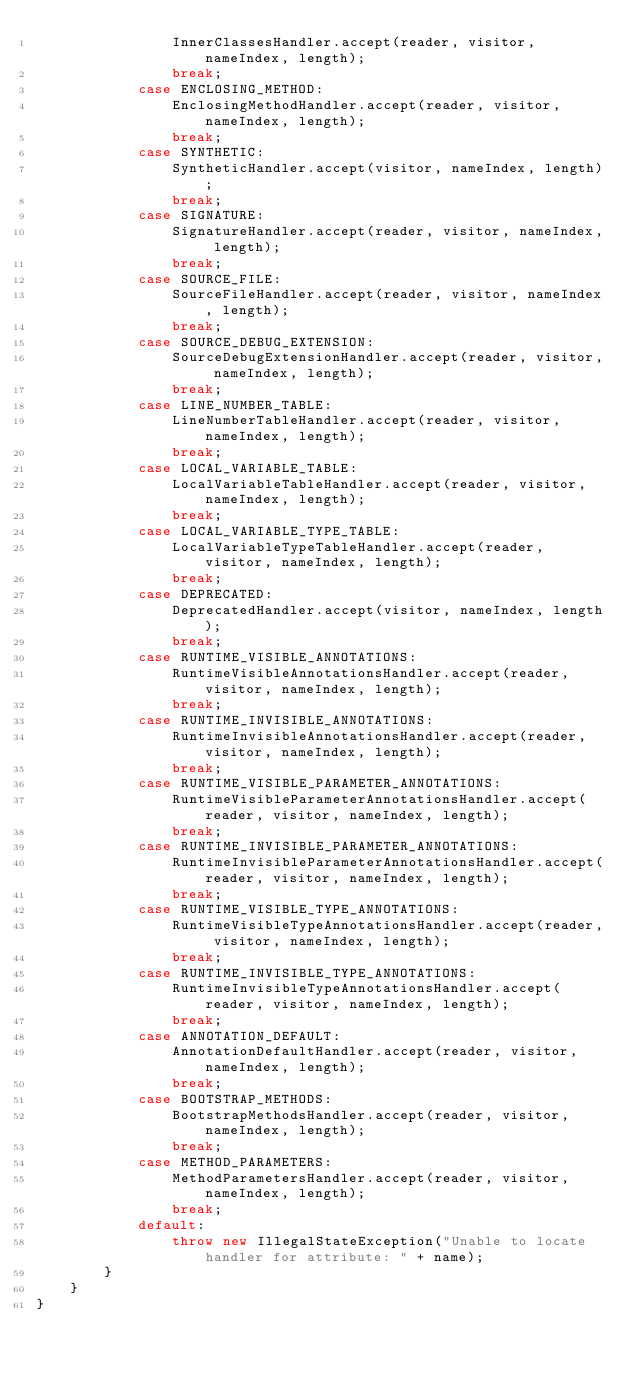<code> <loc_0><loc_0><loc_500><loc_500><_Java_>                InnerClassesHandler.accept(reader, visitor, nameIndex, length);
                break;
            case ENCLOSING_METHOD:
                EnclosingMethodHandler.accept(reader, visitor, nameIndex, length);
                break;
            case SYNTHETIC:
                SyntheticHandler.accept(visitor, nameIndex, length);
                break;
            case SIGNATURE:
                SignatureHandler.accept(reader, visitor, nameIndex, length);
                break;
            case SOURCE_FILE:
                SourceFileHandler.accept(reader, visitor, nameIndex, length);
                break;
            case SOURCE_DEBUG_EXTENSION:
                SourceDebugExtensionHandler.accept(reader, visitor, nameIndex, length);
                break;
            case LINE_NUMBER_TABLE:
                LineNumberTableHandler.accept(reader, visitor, nameIndex, length);
                break;
            case LOCAL_VARIABLE_TABLE:
                LocalVariableTableHandler.accept(reader, visitor, nameIndex, length);
                break;
            case LOCAL_VARIABLE_TYPE_TABLE:
                LocalVariableTypeTableHandler.accept(reader, visitor, nameIndex, length);
                break;
            case DEPRECATED:
                DeprecatedHandler.accept(visitor, nameIndex, length);
                break;
            case RUNTIME_VISIBLE_ANNOTATIONS:
                RuntimeVisibleAnnotationsHandler.accept(reader, visitor, nameIndex, length);
                break;
            case RUNTIME_INVISIBLE_ANNOTATIONS:
                RuntimeInvisibleAnnotationsHandler.accept(reader, visitor, nameIndex, length);
                break;
            case RUNTIME_VISIBLE_PARAMETER_ANNOTATIONS:
                RuntimeVisibleParameterAnnotationsHandler.accept(reader, visitor, nameIndex, length);
                break;
            case RUNTIME_INVISIBLE_PARAMETER_ANNOTATIONS:
                RuntimeInvisibleParameterAnnotationsHandler.accept(reader, visitor, nameIndex, length);
                break;
            case RUNTIME_VISIBLE_TYPE_ANNOTATIONS:
                RuntimeVisibleTypeAnnotationsHandler.accept(reader, visitor, nameIndex, length);
                break;
            case RUNTIME_INVISIBLE_TYPE_ANNOTATIONS:
                RuntimeInvisibleTypeAnnotationsHandler.accept(reader, visitor, nameIndex, length);
                break;
            case ANNOTATION_DEFAULT:
                AnnotationDefaultHandler.accept(reader, visitor, nameIndex, length);
                break;
            case BOOTSTRAP_METHODS:
                BootstrapMethodsHandler.accept(reader, visitor, nameIndex, length);
                break;
            case METHOD_PARAMETERS:
                MethodParametersHandler.accept(reader, visitor, nameIndex, length);
                break;
            default:
                throw new IllegalStateException("Unable to locate handler for attribute: " + name);
        }
    }
}</code> 